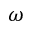Convert formula to latex. <formula><loc_0><loc_0><loc_500><loc_500>\omega</formula> 